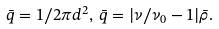Convert formula to latex. <formula><loc_0><loc_0><loc_500><loc_500>\bar { q } = 1 / 2 \pi d ^ { 2 } , \, \bar { q } = | \nu / \nu _ { 0 } - 1 | \bar { \rho } .</formula> 